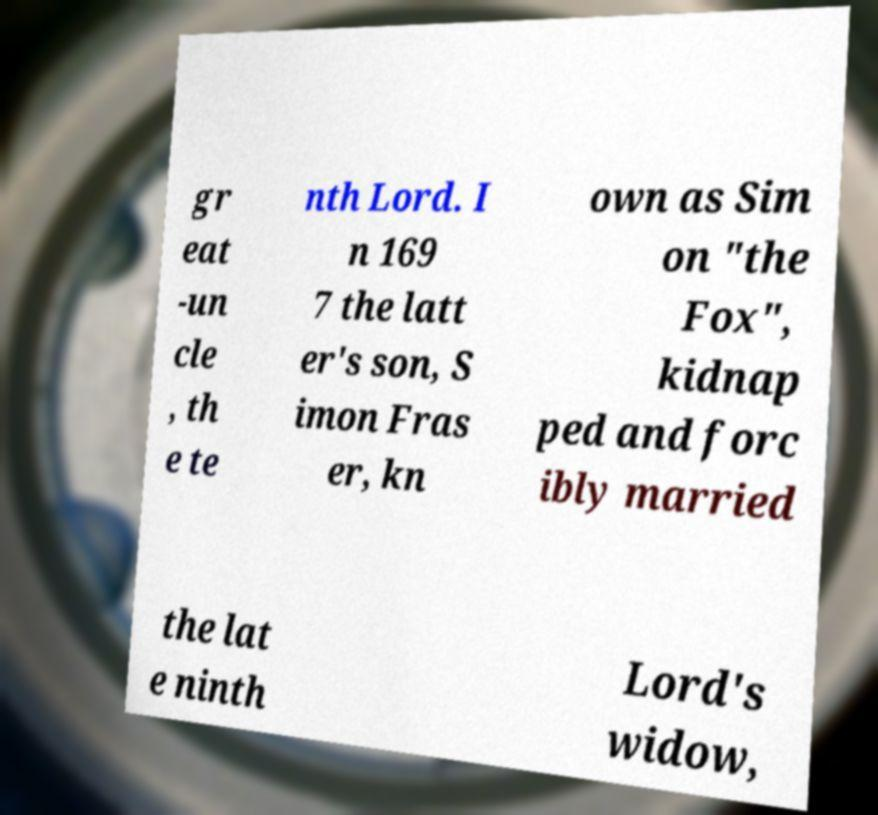Can you read and provide the text displayed in the image?This photo seems to have some interesting text. Can you extract and type it out for me? gr eat -un cle , th e te nth Lord. I n 169 7 the latt er's son, S imon Fras er, kn own as Sim on "the Fox", kidnap ped and forc ibly married the lat e ninth Lord's widow, 